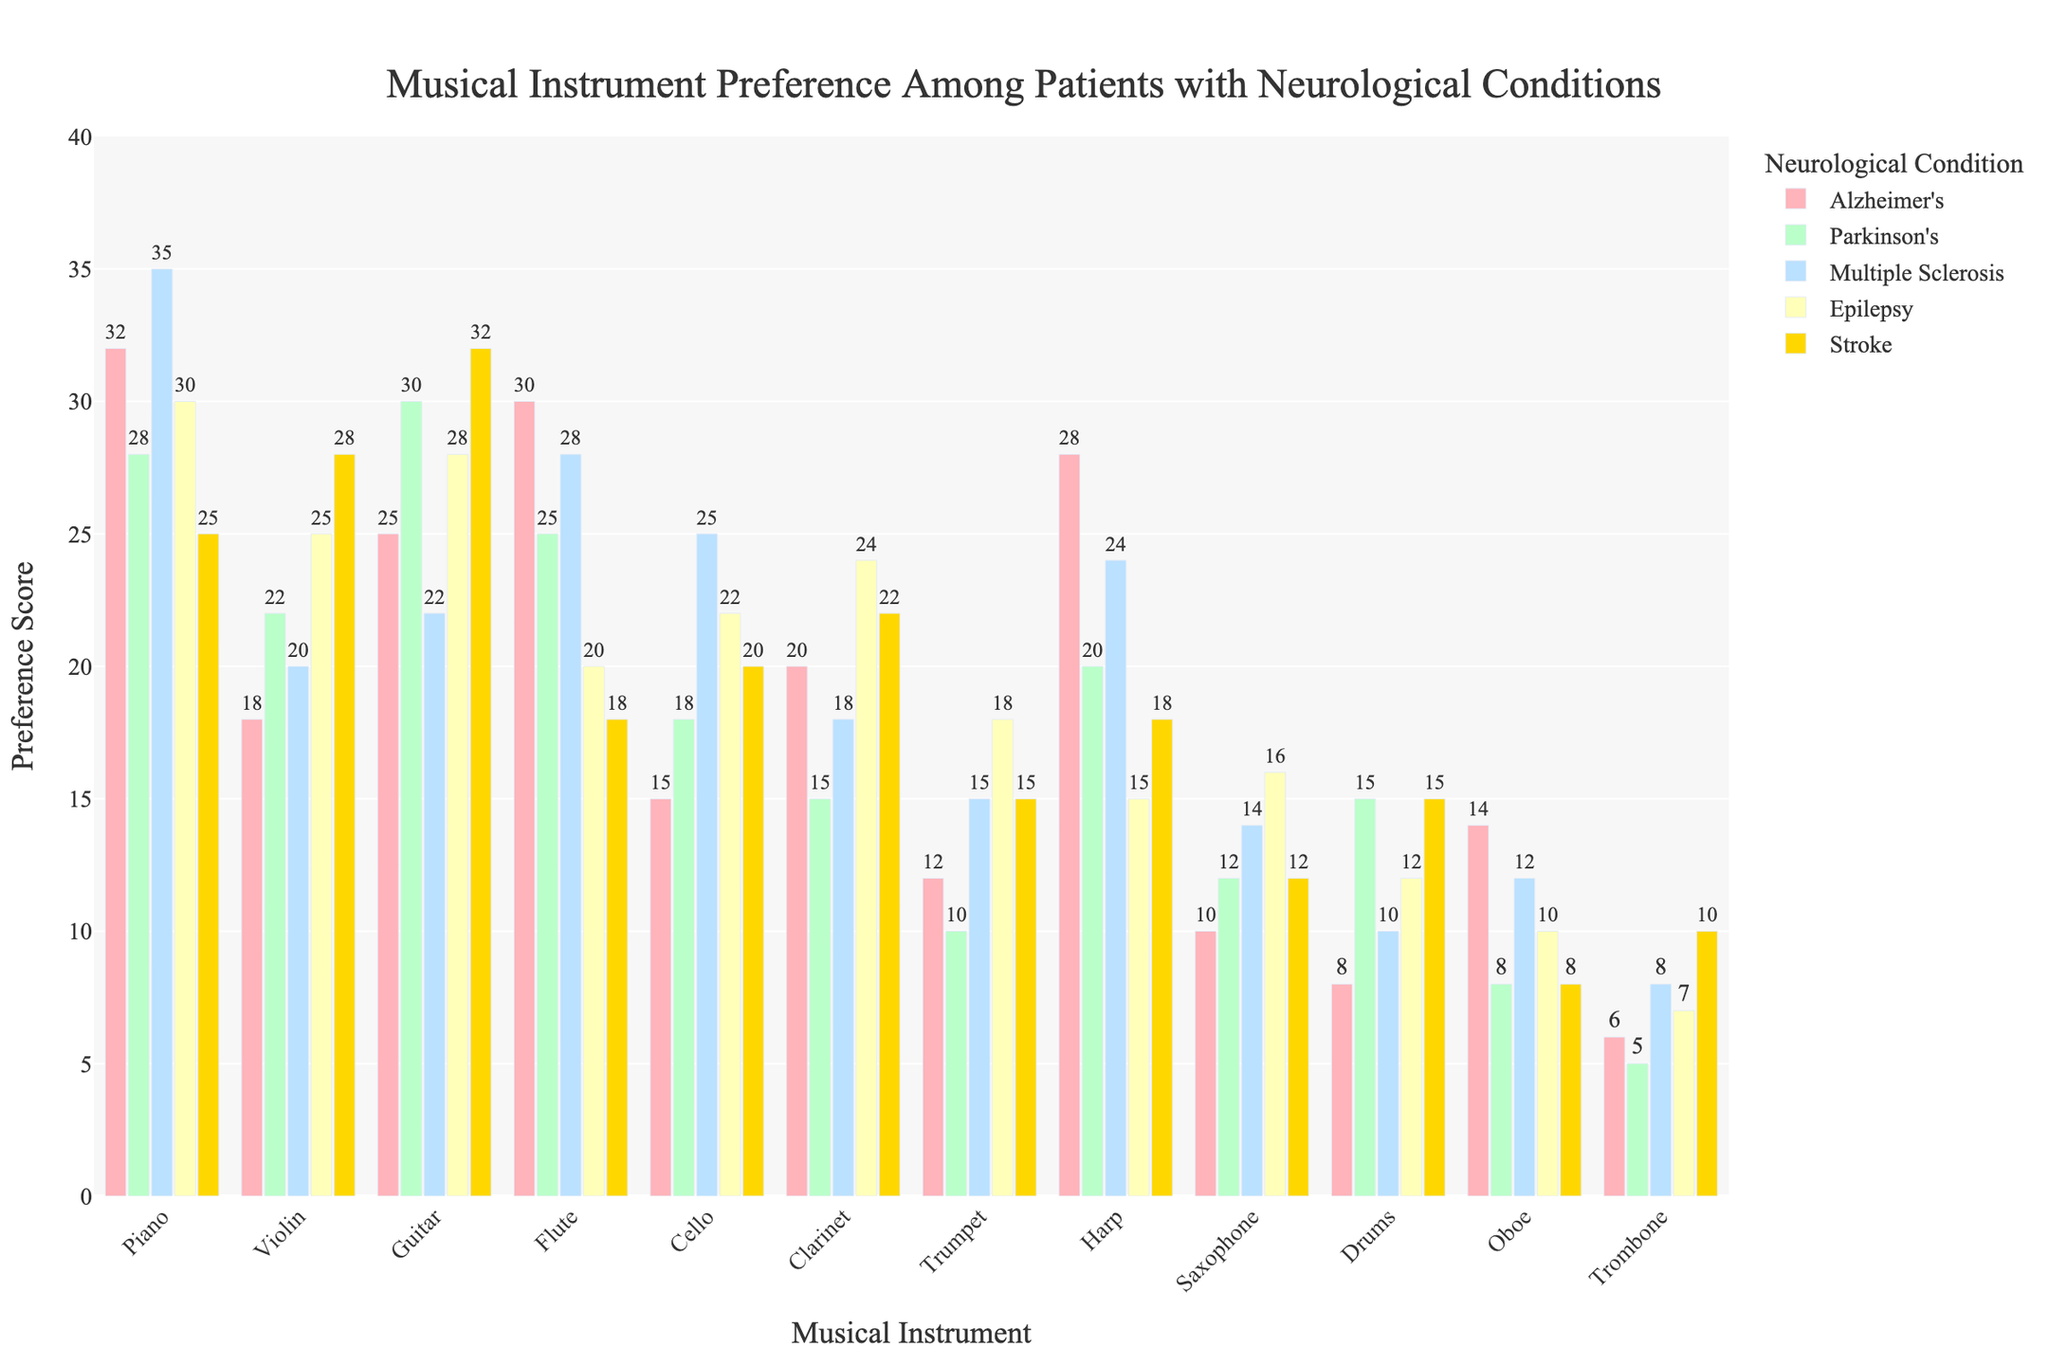Which instrument is preferred the most by patients with Parkinson's? By examining the height of the bars for Parkinson's patients, we see that Guitar has the highest preference score among this group.
Answer: Guitar Which instrument has the least preference score for Stroke patients? By comparing the heights of the bars for Stroke patients, the Oboe has the smallest bar, indicating the least preference.
Answer: Oboe What is the total preference score for the Piano and Violin among Alzheimer's patients? Sum the preference scores of Piano (32) and Violin (18) for Alzheimer's patients. 32 + 18 = 50
Answer: 50 Is there any instrument that has a preference score of exactly 20 for Flute across multiple neurological conditions? Check the preference scores for Flute in each condition and see that only in Epilepsy the score is exactly 20.
Answer: No How does the preference for the Cello among Multiple Sclerosis patients compare to the preference for the Harp among Stroke patients? The preference for the Cello among Multiple Sclerosis patients is 25, which is higher than the preference for the Harp among Stroke patients, which is 18.
Answer: Cello among Multiple Sclerosis patients Which condition has the most diverse range of instrument preferences? By observing the range of heights of bars within each condition, Alzheimer's appears to have a wide range from 6 (Trombone) to 32 (Piano).
Answer: Alzheimer's Are there more patients preferring the Flute or the Clarinet across all neurological conditions combined? Sum the preference scores for Flute (30+25+28+20+18=121) and Clarinet (20+15+18+24+22=99). The total for Flute is higher than that of Clarinet.
Answer: Flute Which condition has the equal preference scores for the Saxophone and the Drums? By checking the preference scores for Saxophone and Drums in each condition, we find that only Stroke has equal preference scores of 12.
Answer: Stroke What is the average preference score for the Harp across all neurological conditions? Sum the preference scores for the Harp (28, 20, 24, 15, 18) and divide by the number of conditions: (28+20+24+15+18)/5 = 21
Answer: 21 Is the preference score for the Violin higher for Stroke patients compared to Multiple Sclerosis patients? The preference score for the Violin for Stroke patients is 28, while for Multiple Sclerosis patients it is 20. Yes, the score for Stroke patients is higher.
Answer: Yes 